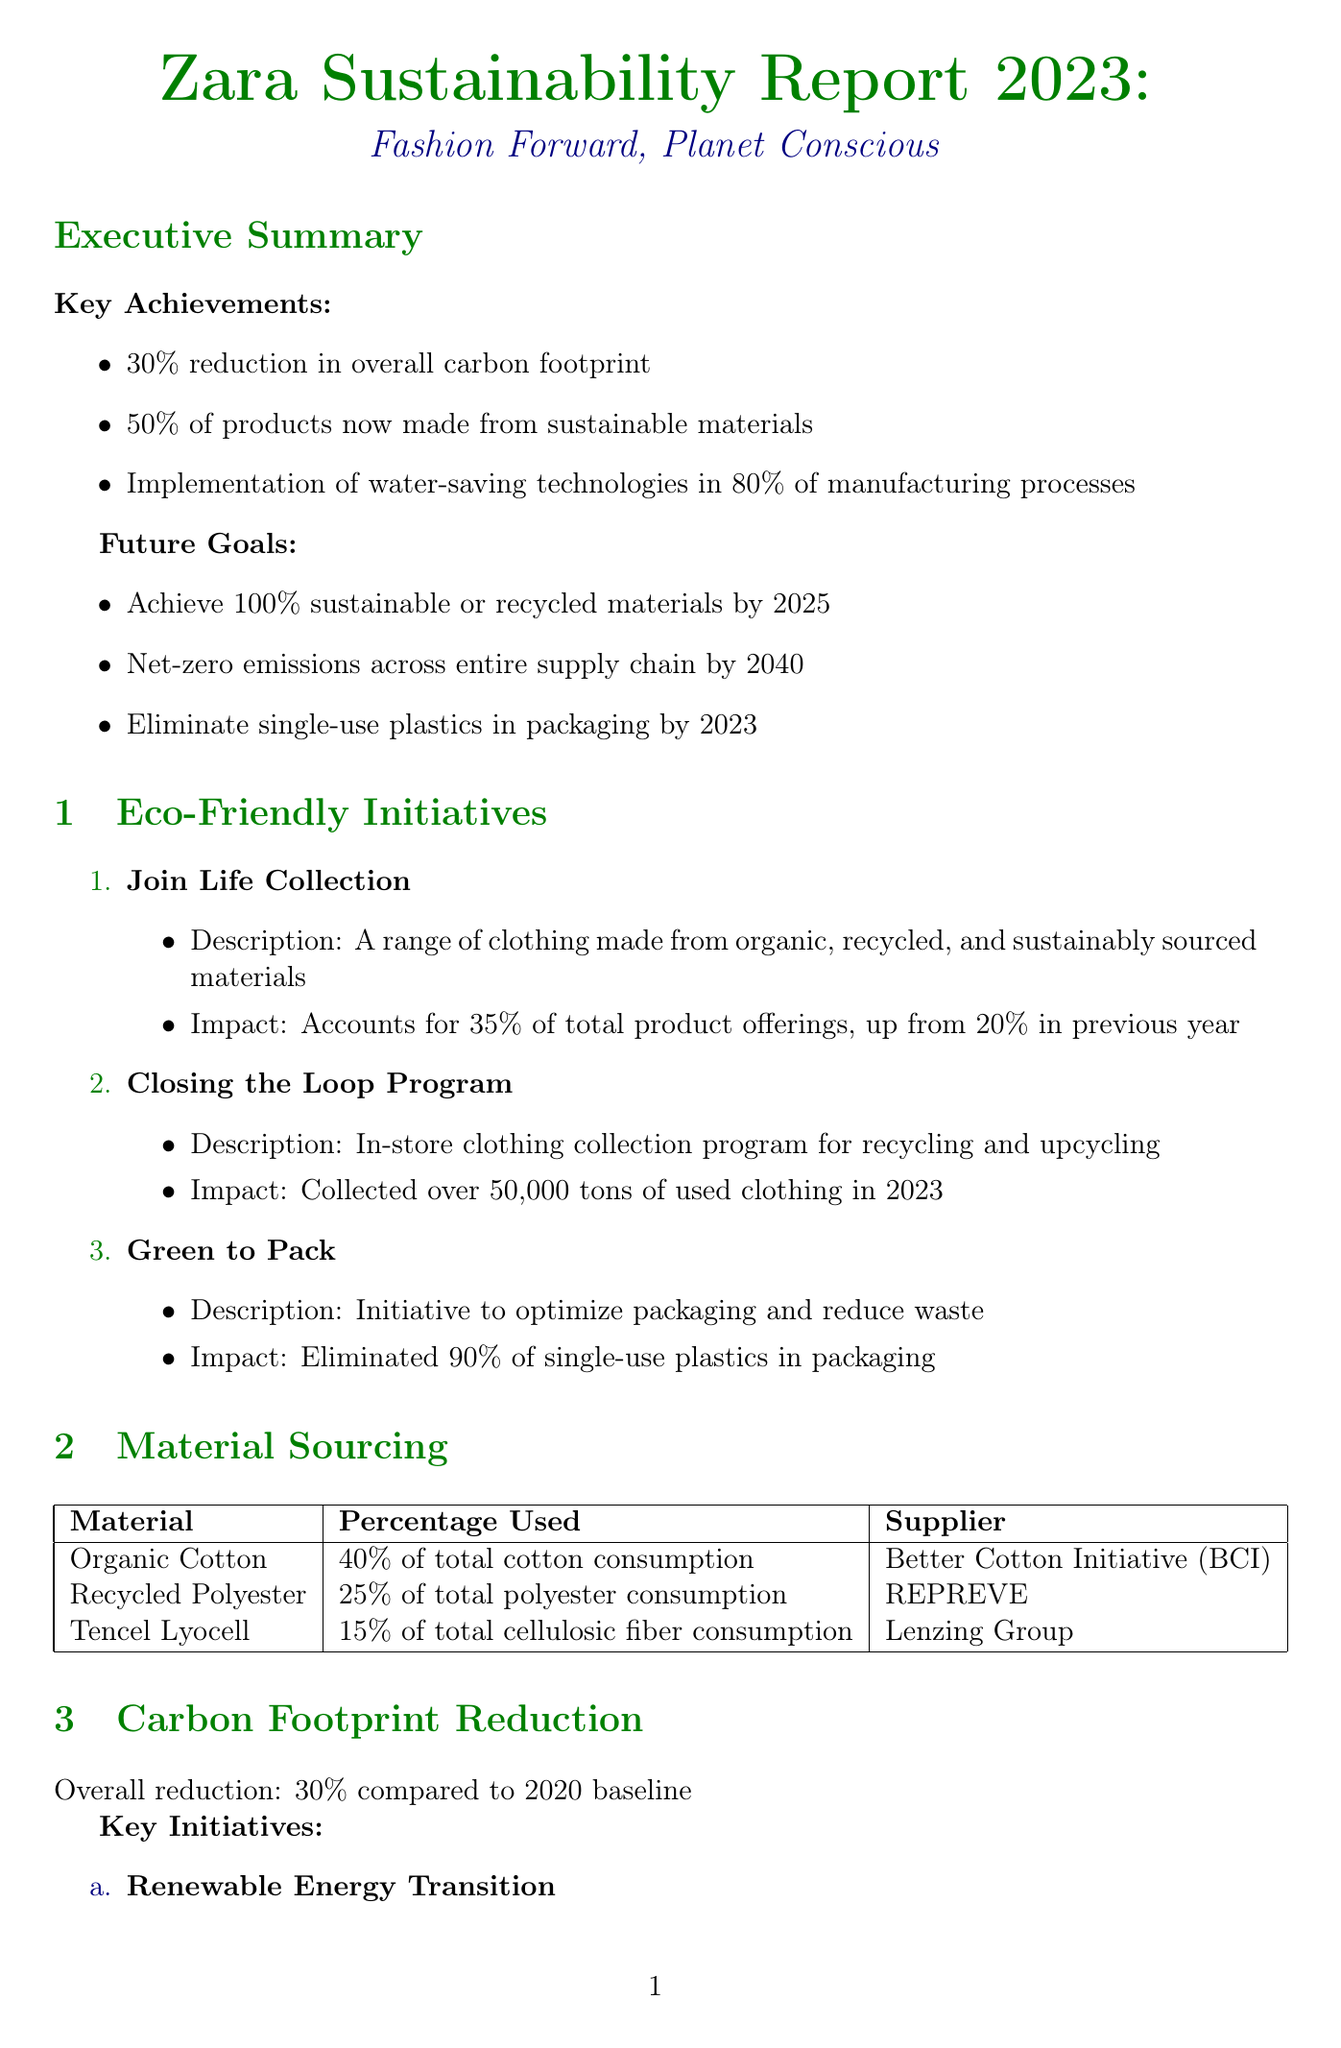What is the reduction in overall carbon footprint? The carbon footprint reduction is stated in the Executive Summary as a percentage compared to a 2020 baseline.
Answer: 30% How much of Zara's products are made from sustainable materials? The report mentions that a certain percentage of products are now made from sustainable materials, highlighting a key achievement.
Answer: 50% What initiative accounts for 35% of total product offerings? The document specifies an initiative related to clothing made from sustainable materials that contributes to the product offering percentage.
Answer: Join Life Collection What is the goal for sustainable or recycled materials by 2025? The future goals include achieving a certain percentage of sustainable or recycled materials within a specified year.
Answer: 100% How many audits were conducted for ethical labor practices? The document provides a specific figure regarding the number of audits conducted as part of ethical labor practices.
Answer: 12000 What percentage of total cotton consumption is organic cotton? The material sourcing section indicates the percentage representation of organic cotton consumption.
Answer: 40% What is the total water saved compared to 2020? The report details the amount of water saved in comparison to a previous year, providing a measurable figure.
Answer: 1.5 billion liters Which organization is partnered for the initiative "Make Fashion Circular"? The sustainability partnerships section lists organizations involved in specific sustainability initiatives.
Answer: Ellen MacArthur Foundation What type of technologies were implemented for water conservation? The report specifics initiatives related to water savings and conservation within Zara's operations.
Answer: Waterless dyeing technologies 